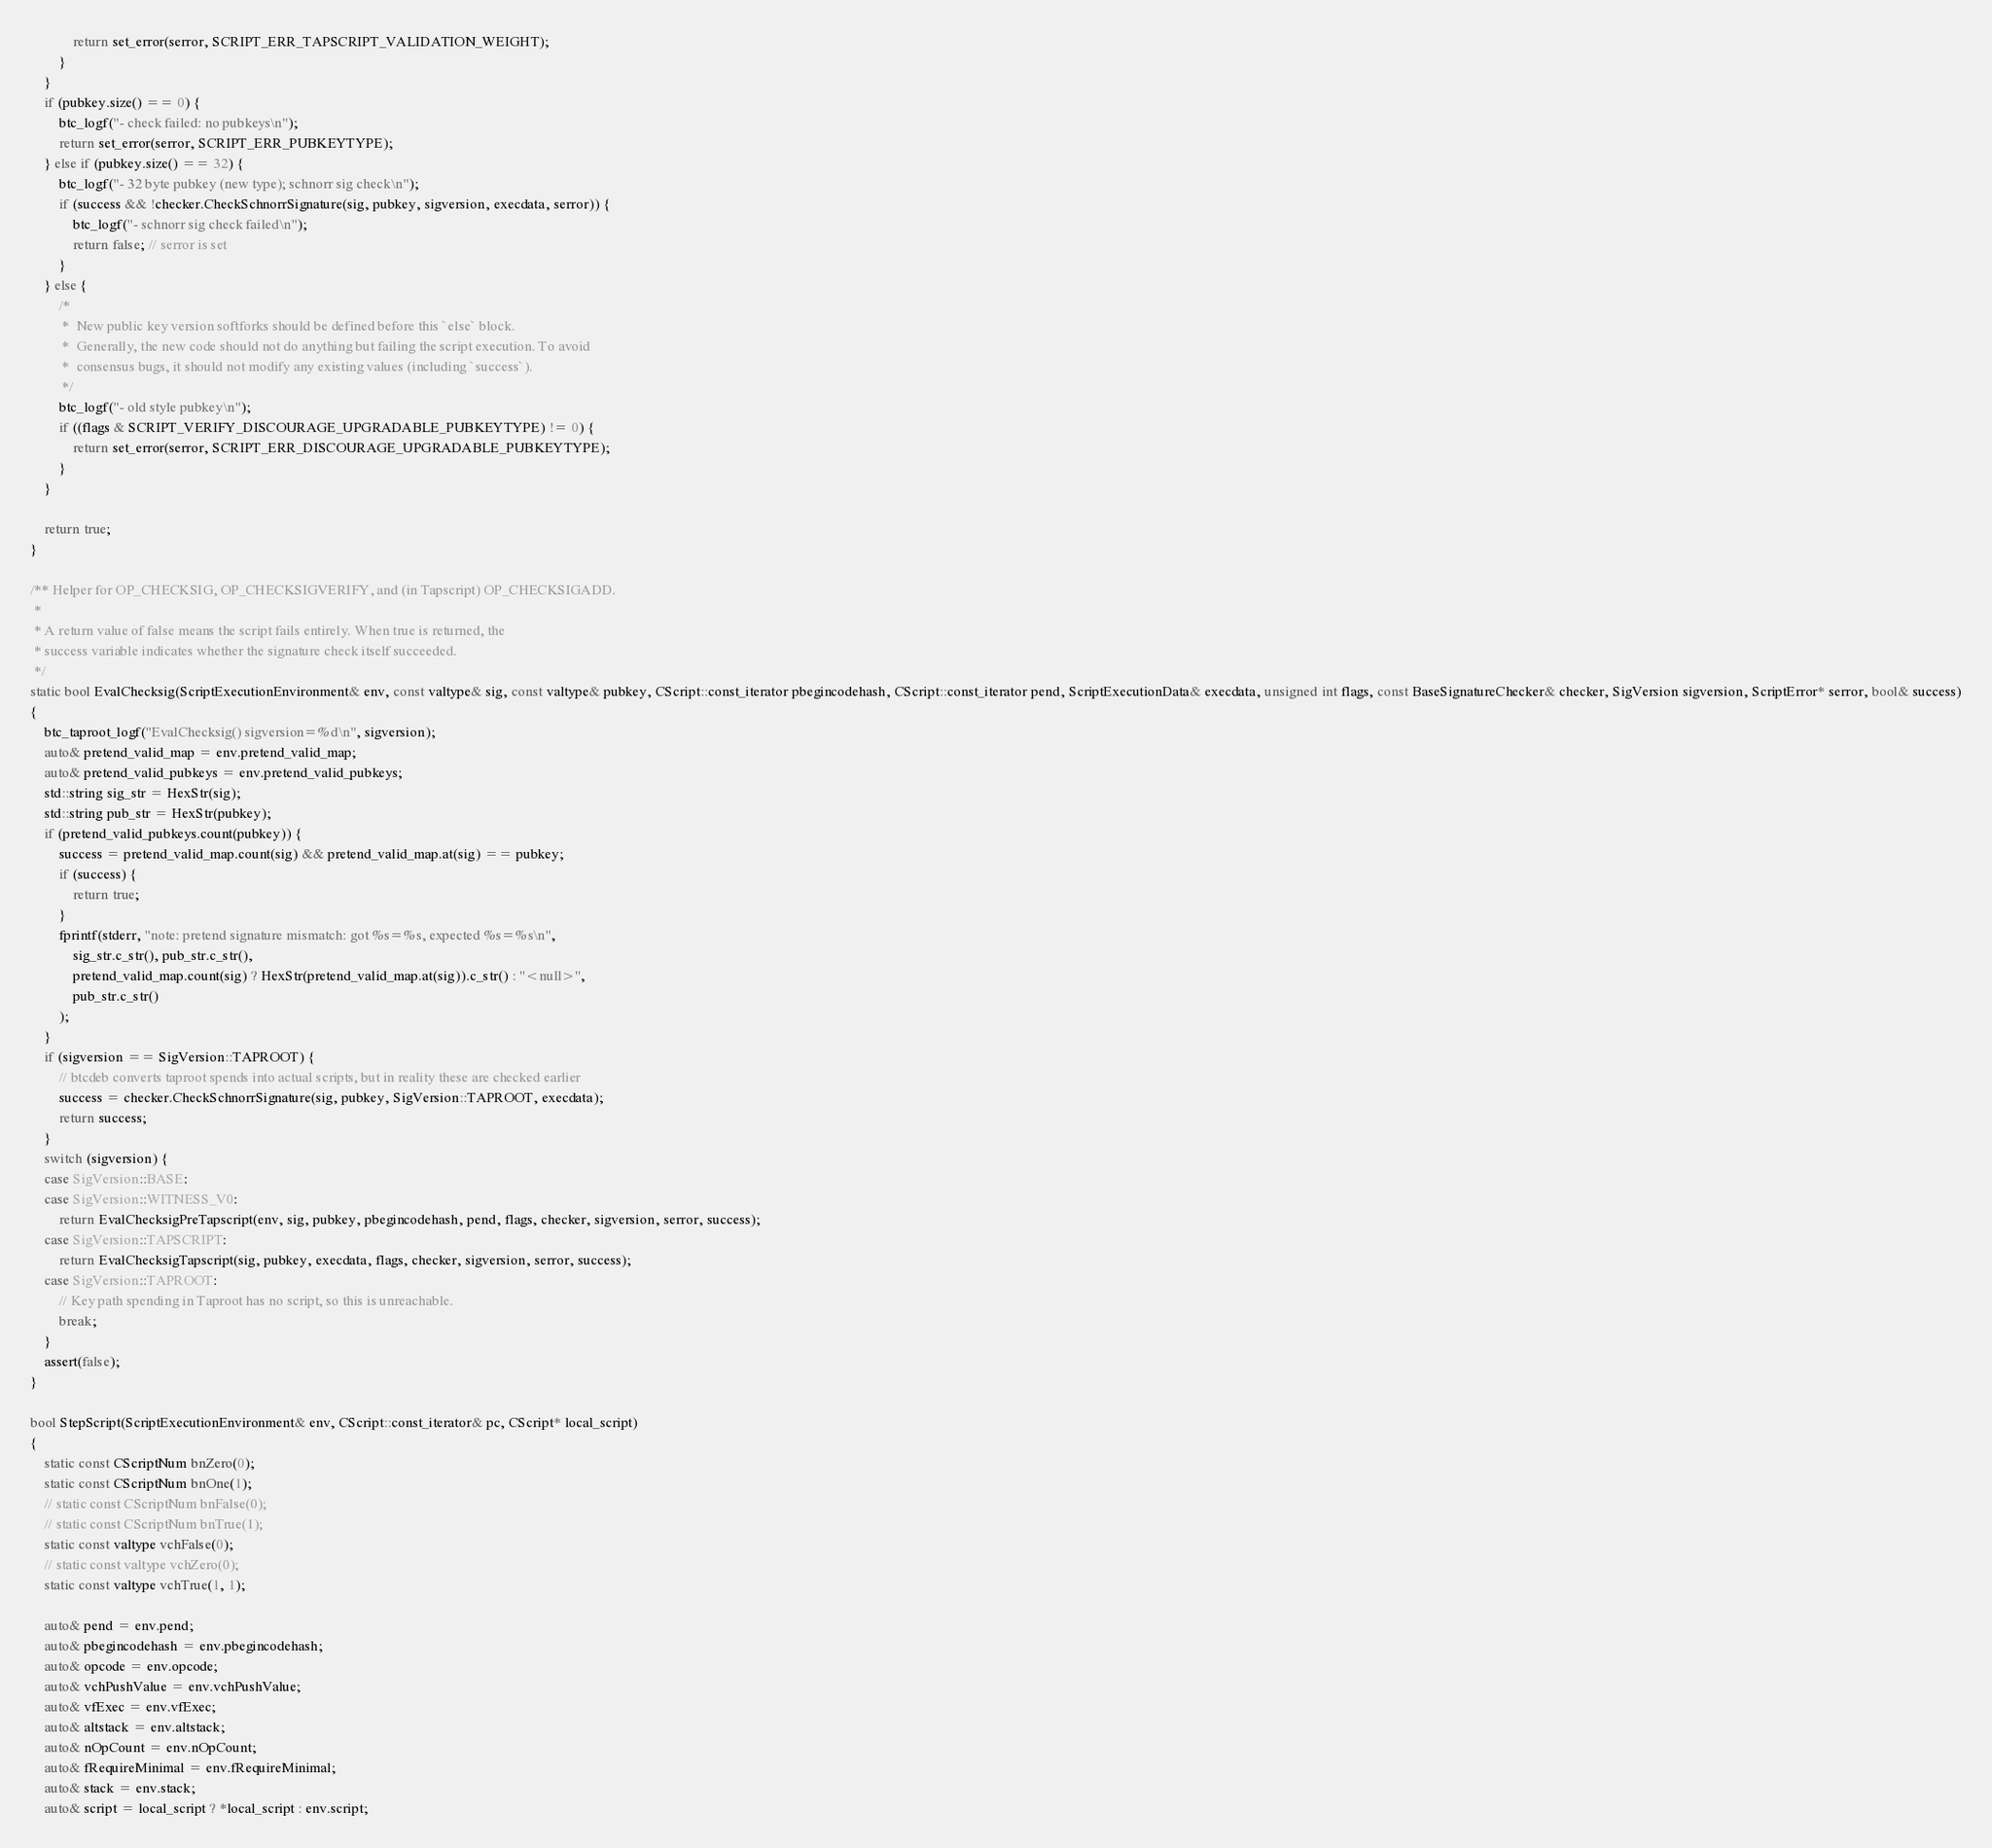Convert code to text. <code><loc_0><loc_0><loc_500><loc_500><_C++_>            return set_error(serror, SCRIPT_ERR_TAPSCRIPT_VALIDATION_WEIGHT);
        }
    }
    if (pubkey.size() == 0) {
        btc_logf("- check failed: no pubkeys\n");
        return set_error(serror, SCRIPT_ERR_PUBKEYTYPE);
    } else if (pubkey.size() == 32) {
        btc_logf("- 32 byte pubkey (new type); schnorr sig check\n");
        if (success && !checker.CheckSchnorrSignature(sig, pubkey, sigversion, execdata, serror)) {
            btc_logf("- schnorr sig check failed\n");
            return false; // serror is set
        }
    } else {
        /*
         *  New public key version softforks should be defined before this `else` block.
         *  Generally, the new code should not do anything but failing the script execution. To avoid
         *  consensus bugs, it should not modify any existing values (including `success`).
         */
        btc_logf("- old style pubkey\n");
        if ((flags & SCRIPT_VERIFY_DISCOURAGE_UPGRADABLE_PUBKEYTYPE) != 0) {
            return set_error(serror, SCRIPT_ERR_DISCOURAGE_UPGRADABLE_PUBKEYTYPE);
        }
    }

    return true;
}

/** Helper for OP_CHECKSIG, OP_CHECKSIGVERIFY, and (in Tapscript) OP_CHECKSIGADD.
 *
 * A return value of false means the script fails entirely. When true is returned, the
 * success variable indicates whether the signature check itself succeeded.
 */
static bool EvalChecksig(ScriptExecutionEnvironment& env, const valtype& sig, const valtype& pubkey, CScript::const_iterator pbegincodehash, CScript::const_iterator pend, ScriptExecutionData& execdata, unsigned int flags, const BaseSignatureChecker& checker, SigVersion sigversion, ScriptError* serror, bool& success)
{
    btc_taproot_logf("EvalChecksig() sigversion=%d\n", sigversion);
    auto& pretend_valid_map = env.pretend_valid_map;
    auto& pretend_valid_pubkeys = env.pretend_valid_pubkeys;
    std::string sig_str = HexStr(sig);
    std::string pub_str = HexStr(pubkey);
    if (pretend_valid_pubkeys.count(pubkey)) {
        success = pretend_valid_map.count(sig) && pretend_valid_map.at(sig) == pubkey;
        if (success) {
            return true;
        }
        fprintf(stderr, "note: pretend signature mismatch: got %s=%s, expected %s=%s\n",
            sig_str.c_str(), pub_str.c_str(),
            pretend_valid_map.count(sig) ? HexStr(pretend_valid_map.at(sig)).c_str() : "<null>",
            pub_str.c_str()
        );
    }
    if (sigversion == SigVersion::TAPROOT) {
        // btcdeb converts taproot spends into actual scripts, but in reality these are checked earlier
        success = checker.CheckSchnorrSignature(sig, pubkey, SigVersion::TAPROOT, execdata);
        return success;
    }
    switch (sigversion) {
    case SigVersion::BASE:
    case SigVersion::WITNESS_V0:
        return EvalChecksigPreTapscript(env, sig, pubkey, pbegincodehash, pend, flags, checker, sigversion, serror, success);
    case SigVersion::TAPSCRIPT:
        return EvalChecksigTapscript(sig, pubkey, execdata, flags, checker, sigversion, serror, success);
    case SigVersion::TAPROOT:
        // Key path spending in Taproot has no script, so this is unreachable.
        break;
    }
    assert(false);
}

bool StepScript(ScriptExecutionEnvironment& env, CScript::const_iterator& pc, CScript* local_script)
{
    static const CScriptNum bnZero(0);
    static const CScriptNum bnOne(1);
    // static const CScriptNum bnFalse(0);
    // static const CScriptNum bnTrue(1);
    static const valtype vchFalse(0);
    // static const valtype vchZero(0);
    static const valtype vchTrue(1, 1);

    auto& pend = env.pend;
    auto& pbegincodehash = env.pbegincodehash;
    auto& opcode = env.opcode;
    auto& vchPushValue = env.vchPushValue;
    auto& vfExec = env.vfExec;
    auto& altstack = env.altstack;
    auto& nOpCount = env.nOpCount;
    auto& fRequireMinimal = env.fRequireMinimal;
    auto& stack = env.stack;
    auto& script = local_script ? *local_script : env.script;</code> 